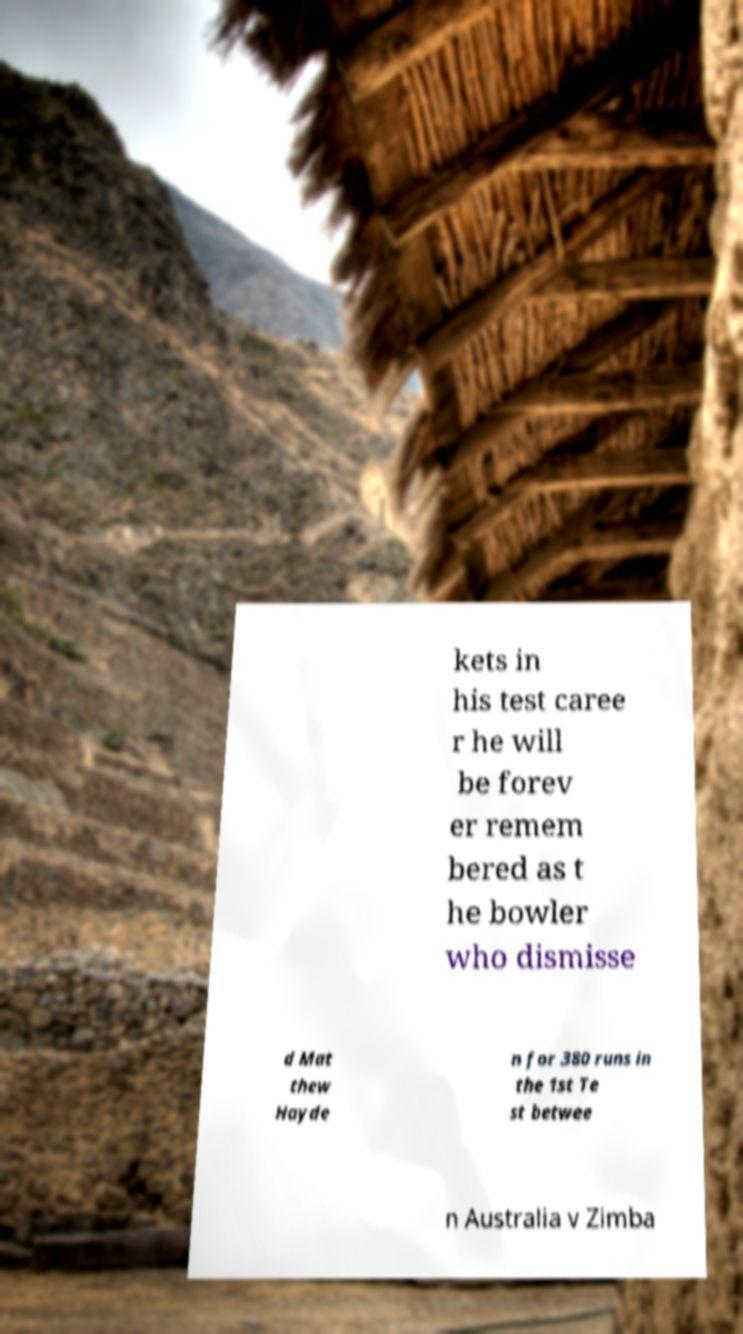What messages or text are displayed in this image? I need them in a readable, typed format. kets in his test caree r he will be forev er remem bered as t he bowler who dismisse d Mat thew Hayde n for 380 runs in the 1st Te st betwee n Australia v Zimba 